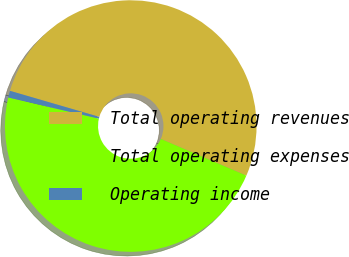<chart> <loc_0><loc_0><loc_500><loc_500><pie_chart><fcel>Total operating revenues<fcel>Total operating expenses<fcel>Operating income<nl><fcel>51.93%<fcel>47.21%<fcel>0.86%<nl></chart> 